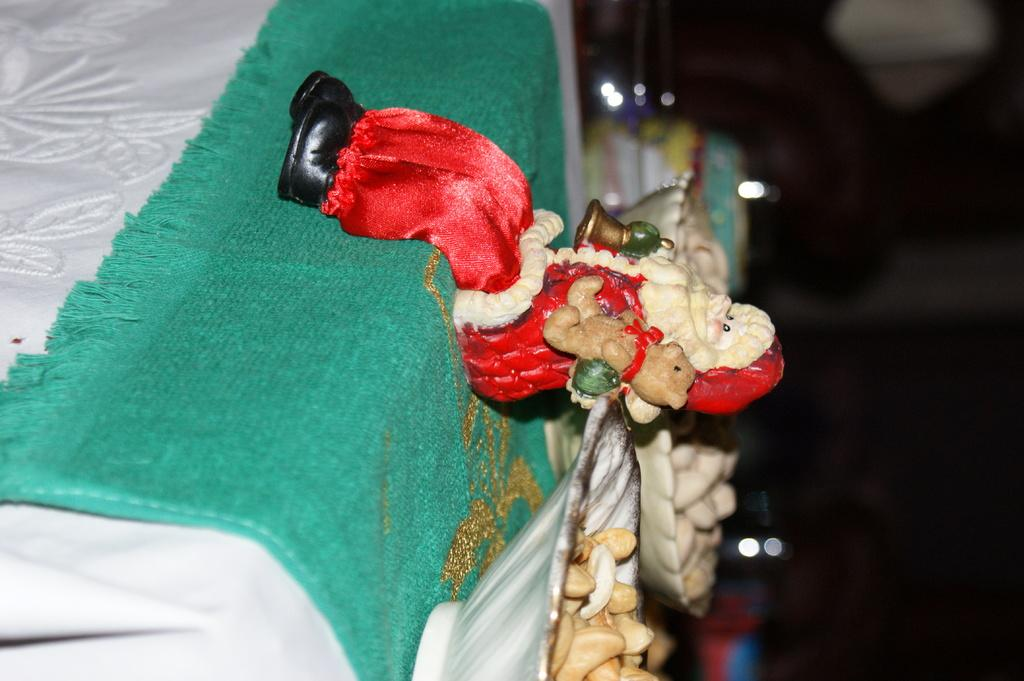What object in the image is typically used for play? There is a toy in the image. What type of items are in the bowls in the image? There are food items in the bowls. What is the bowls resting on in the image? The bowls are on a cloth. What can be observed about the background of the image? The background of the image is dark. How many girls are visible in the image? There are no girls present in the image. Is there a fan visible in the image? There is no fan present in the image. 